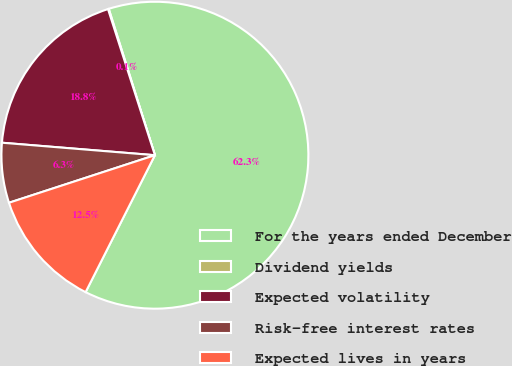Convert chart to OTSL. <chart><loc_0><loc_0><loc_500><loc_500><pie_chart><fcel>For the years ended December<fcel>Dividend yields<fcel>Expected volatility<fcel>Risk-free interest rates<fcel>Expected lives in years<nl><fcel>62.32%<fcel>0.08%<fcel>18.76%<fcel>6.31%<fcel>12.53%<nl></chart> 